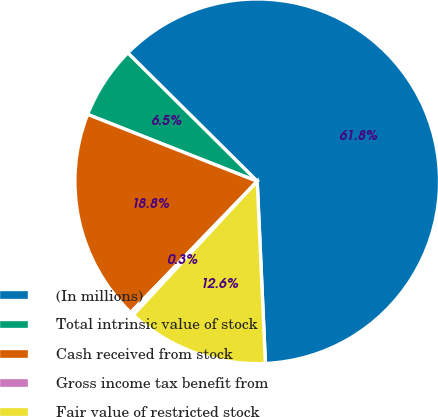<chart> <loc_0><loc_0><loc_500><loc_500><pie_chart><fcel>(In millions)<fcel>Total intrinsic value of stock<fcel>Cash received from stock<fcel>Gross income tax benefit from<fcel>Fair value of restricted stock<nl><fcel>61.85%<fcel>6.46%<fcel>18.77%<fcel>0.31%<fcel>12.62%<nl></chart> 